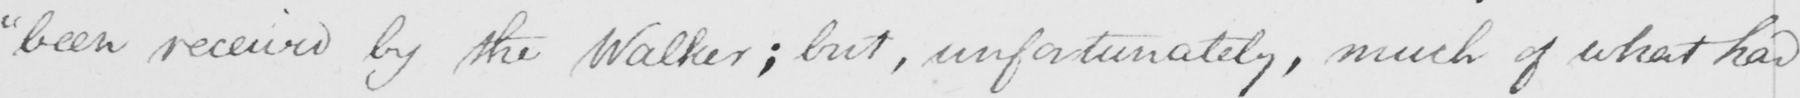What is written in this line of handwriting? " been received by the Walker ; but , unfortunately , much of what had 